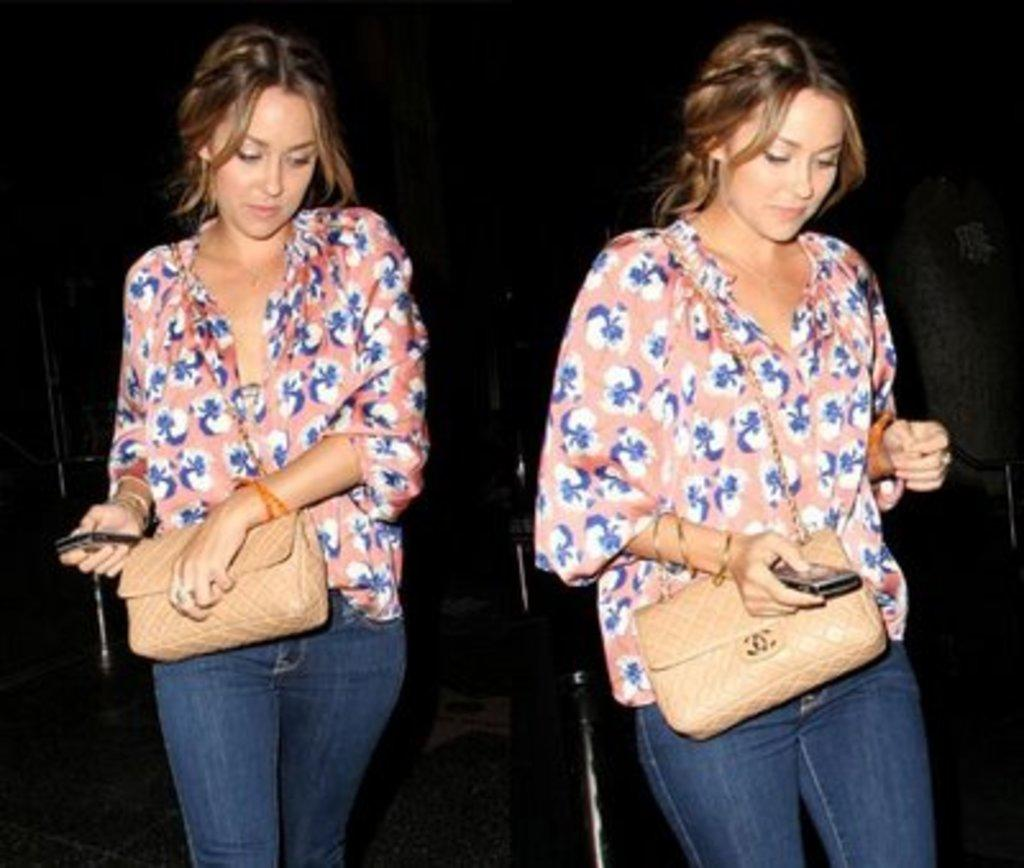How many people are in the image? There are two women in the image. What are the women holding in their hands? The women are holding bags in their hands. What is the purpose of the poisonous rabbits in the image? There are no rabbits, poisonous or otherwise, present in the image. 